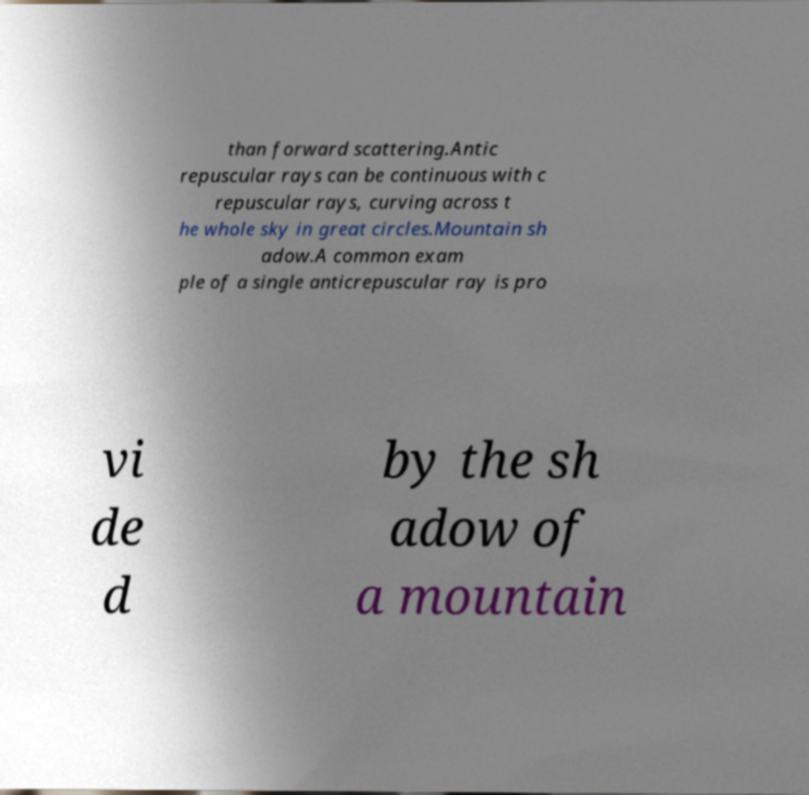For documentation purposes, I need the text within this image transcribed. Could you provide that? than forward scattering.Antic repuscular rays can be continuous with c repuscular rays, curving across t he whole sky in great circles.Mountain sh adow.A common exam ple of a single anticrepuscular ray is pro vi de d by the sh adow of a mountain 